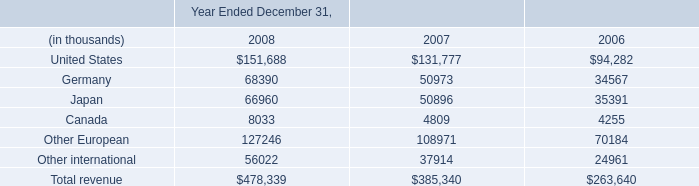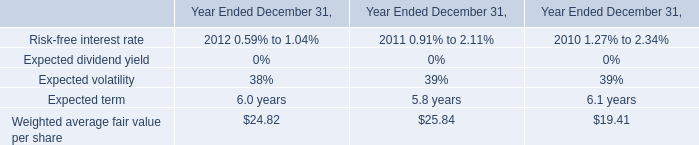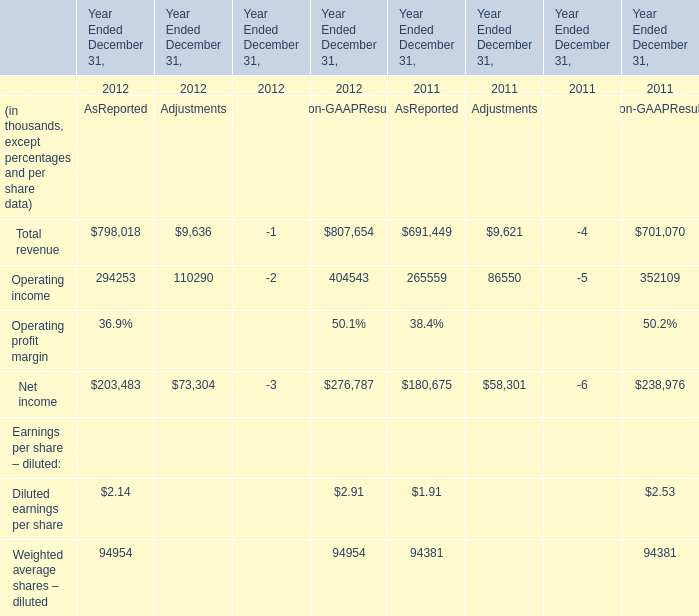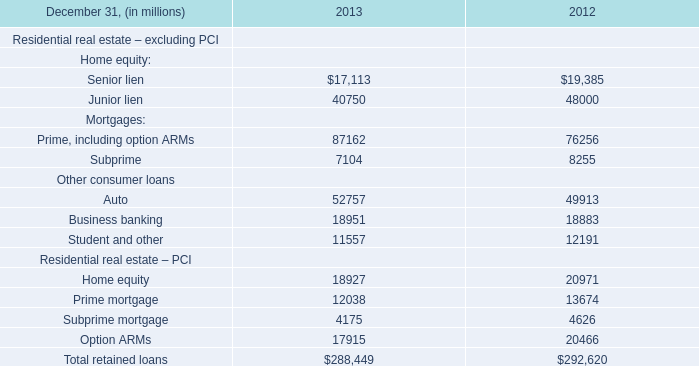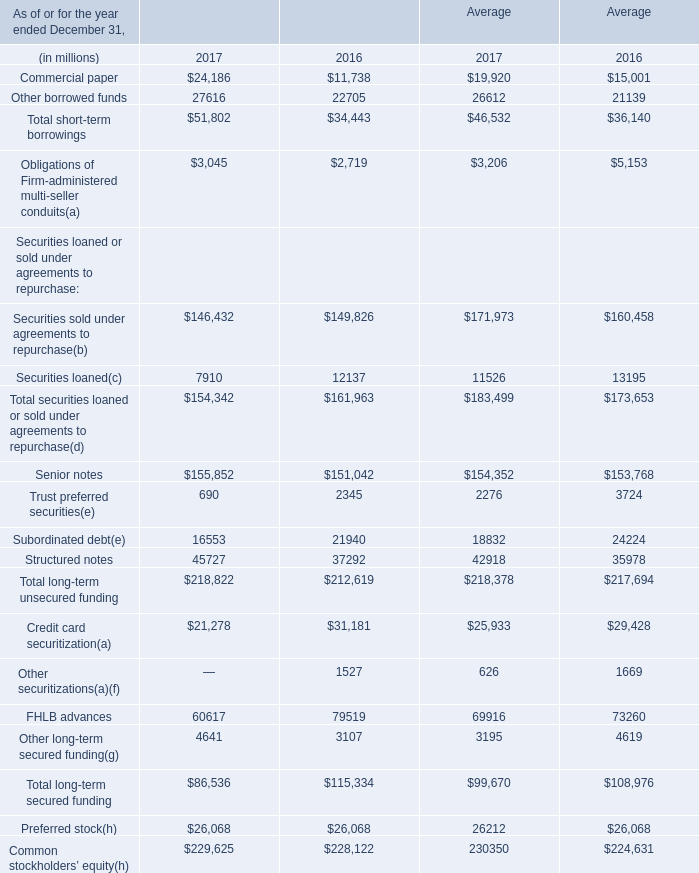What is the average amount of Senior lien of 2012, and United States of Year Ended December 31, 2008 ? 
Computations: ((19385.0 + 151688.0) / 2)
Answer: 85536.5. 